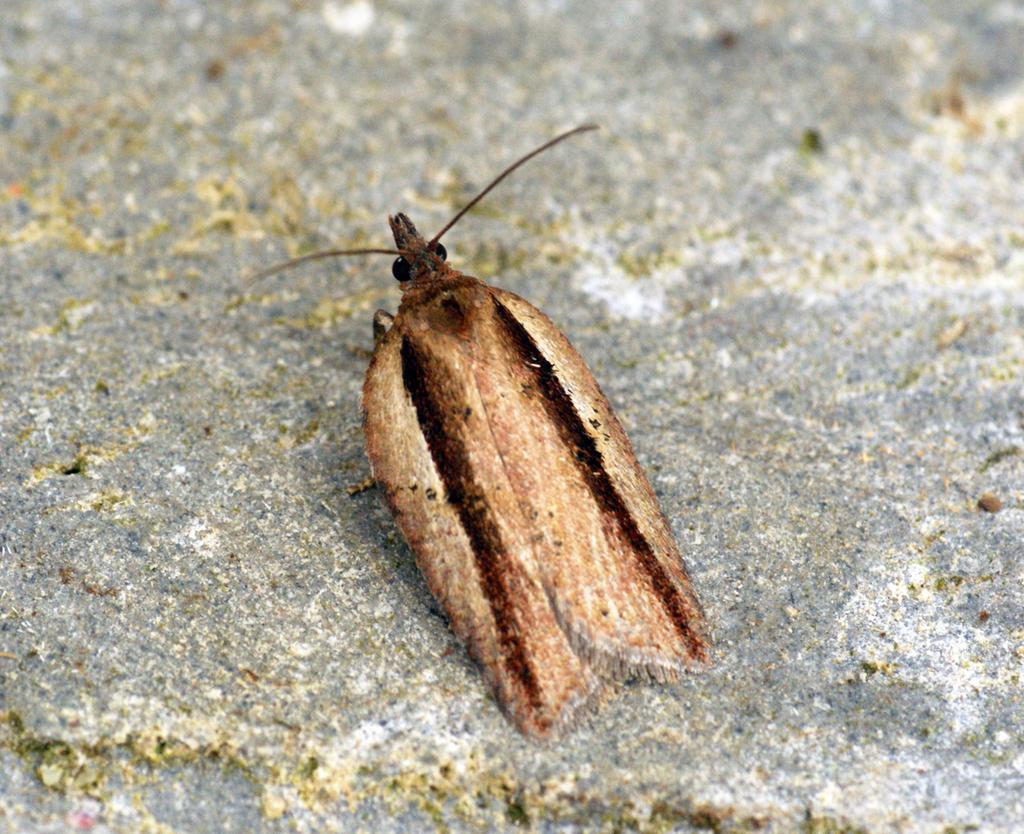What type of insect can be seen in the image? There is a brown color insect in the image. Where is the insect located? The insect is sitting on the concrete ground. What type of glass can be seen in the image? There is no glass present in the image; it only features a brown color insect sitting on the concrete ground. 